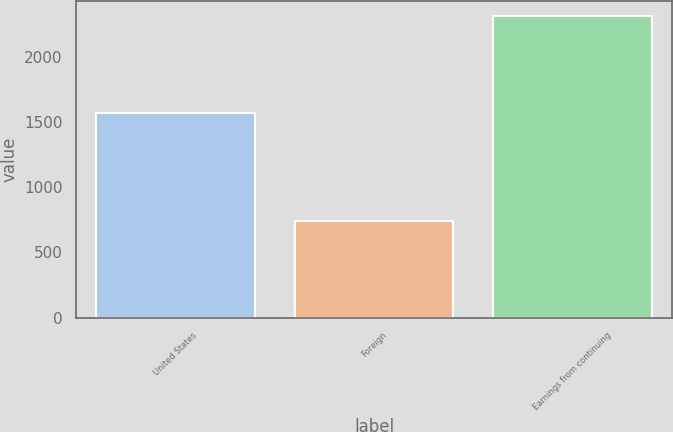Convert chart to OTSL. <chart><loc_0><loc_0><loc_500><loc_500><bar_chart><fcel>United States<fcel>Foreign<fcel>Earnings from continuing<nl><fcel>1571<fcel>742<fcel>2313<nl></chart> 